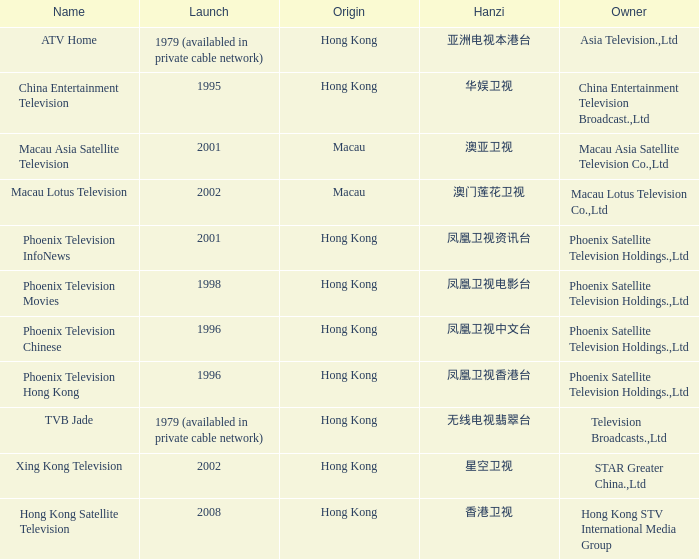Which company launched in 1996 and has a Hanzi of 凤凰卫视中文台? Phoenix Television Chinese. 